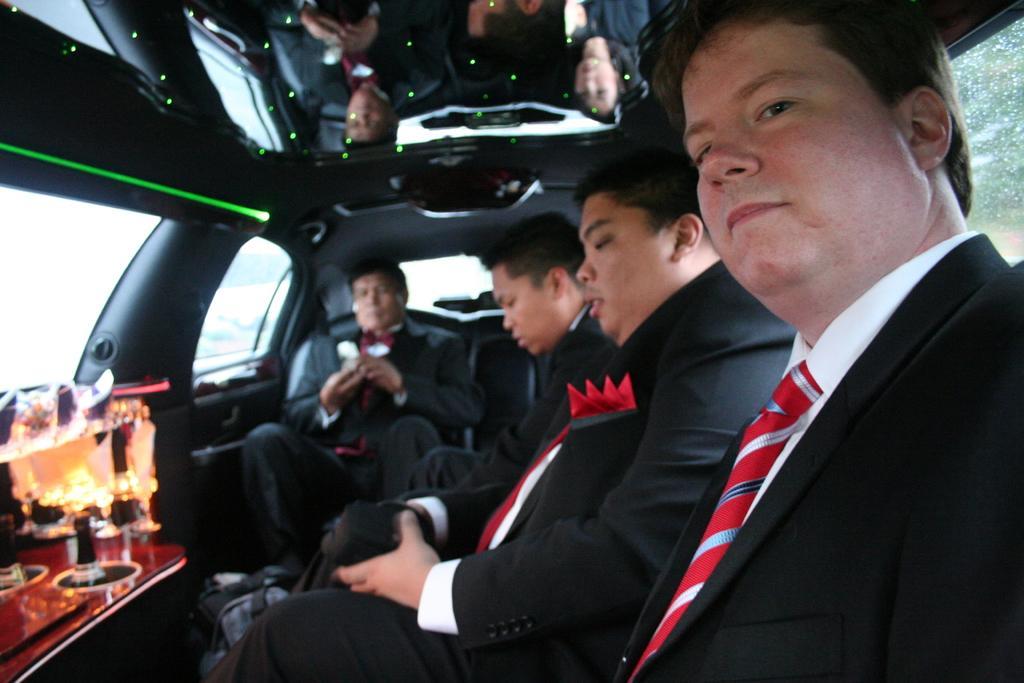How would you summarize this image in a sentence or two? In this picture we can see group of people are seated in the car, in front of them we can find couple of glasses. 